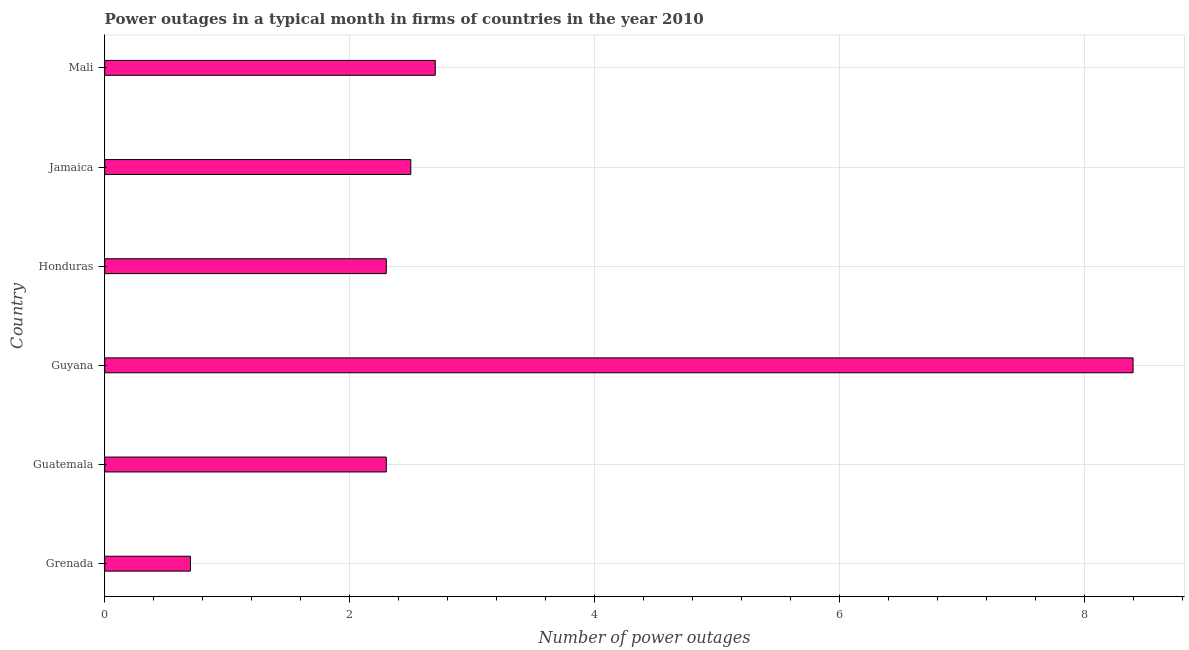Does the graph contain any zero values?
Offer a terse response. No. What is the title of the graph?
Your response must be concise. Power outages in a typical month in firms of countries in the year 2010. What is the label or title of the X-axis?
Your answer should be compact. Number of power outages. What is the label or title of the Y-axis?
Offer a very short reply. Country. What is the number of power outages in Mali?
Your answer should be very brief. 2.7. Across all countries, what is the maximum number of power outages?
Offer a terse response. 8.4. In which country was the number of power outages maximum?
Your answer should be compact. Guyana. In which country was the number of power outages minimum?
Your response must be concise. Grenada. What is the average number of power outages per country?
Your answer should be very brief. 3.15. In how many countries, is the number of power outages greater than 2.8 ?
Provide a short and direct response. 1. What is the ratio of the number of power outages in Guatemala to that in Mali?
Offer a terse response. 0.85. Is the number of power outages in Guatemala less than that in Honduras?
Your response must be concise. No. How many bars are there?
Offer a terse response. 6. Are all the bars in the graph horizontal?
Provide a succinct answer. Yes. How many countries are there in the graph?
Your answer should be very brief. 6. What is the difference between two consecutive major ticks on the X-axis?
Give a very brief answer. 2. Are the values on the major ticks of X-axis written in scientific E-notation?
Ensure brevity in your answer.  No. What is the Number of power outages of Grenada?
Your answer should be compact. 0.7. What is the Number of power outages of Guatemala?
Your answer should be very brief. 2.3. What is the Number of power outages in Guyana?
Keep it short and to the point. 8.4. What is the Number of power outages of Jamaica?
Ensure brevity in your answer.  2.5. What is the difference between the Number of power outages in Grenada and Guatemala?
Provide a succinct answer. -1.6. What is the difference between the Number of power outages in Grenada and Honduras?
Your response must be concise. -1.6. What is the difference between the Number of power outages in Grenada and Mali?
Provide a succinct answer. -2. What is the difference between the Number of power outages in Guatemala and Jamaica?
Your answer should be very brief. -0.2. What is the difference between the Number of power outages in Guyana and Honduras?
Your answer should be very brief. 6.1. What is the difference between the Number of power outages in Guyana and Jamaica?
Provide a short and direct response. 5.9. What is the difference between the Number of power outages in Honduras and Jamaica?
Your answer should be compact. -0.2. What is the ratio of the Number of power outages in Grenada to that in Guatemala?
Offer a very short reply. 0.3. What is the ratio of the Number of power outages in Grenada to that in Guyana?
Your answer should be very brief. 0.08. What is the ratio of the Number of power outages in Grenada to that in Honduras?
Make the answer very short. 0.3. What is the ratio of the Number of power outages in Grenada to that in Jamaica?
Keep it short and to the point. 0.28. What is the ratio of the Number of power outages in Grenada to that in Mali?
Your answer should be compact. 0.26. What is the ratio of the Number of power outages in Guatemala to that in Guyana?
Offer a terse response. 0.27. What is the ratio of the Number of power outages in Guatemala to that in Jamaica?
Offer a very short reply. 0.92. What is the ratio of the Number of power outages in Guatemala to that in Mali?
Ensure brevity in your answer.  0.85. What is the ratio of the Number of power outages in Guyana to that in Honduras?
Your response must be concise. 3.65. What is the ratio of the Number of power outages in Guyana to that in Jamaica?
Give a very brief answer. 3.36. What is the ratio of the Number of power outages in Guyana to that in Mali?
Keep it short and to the point. 3.11. What is the ratio of the Number of power outages in Honduras to that in Mali?
Keep it short and to the point. 0.85. What is the ratio of the Number of power outages in Jamaica to that in Mali?
Make the answer very short. 0.93. 